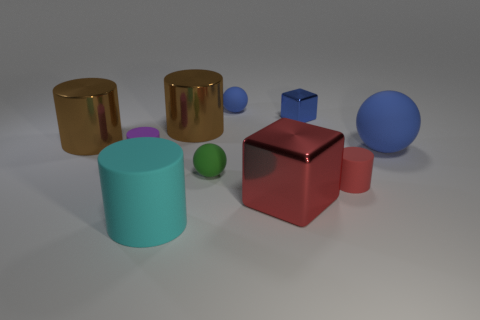There is a small blue matte object; how many blue objects are in front of it?
Offer a terse response. 2. Does the ball behind the large blue rubber object have the same material as the big blue thing?
Your answer should be compact. Yes. What number of other tiny rubber objects have the same shape as the small red thing?
Your response must be concise. 1. What number of tiny things are either blue rubber things or green matte balls?
Offer a very short reply. 2. Do the rubber object in front of the large red metal thing and the large block have the same color?
Ensure brevity in your answer.  No. There is a tiny object that is left of the cyan thing; is it the same color as the rubber object that is right of the small red thing?
Offer a terse response. No. Is there a blue ball that has the same material as the green thing?
Keep it short and to the point. Yes. What number of red objects are tiny rubber things or shiny things?
Ensure brevity in your answer.  2. Are there more tiny purple matte cylinders that are behind the tiny purple object than purple cylinders?
Ensure brevity in your answer.  No. Does the red rubber object have the same size as the red metal cube?
Ensure brevity in your answer.  No. 